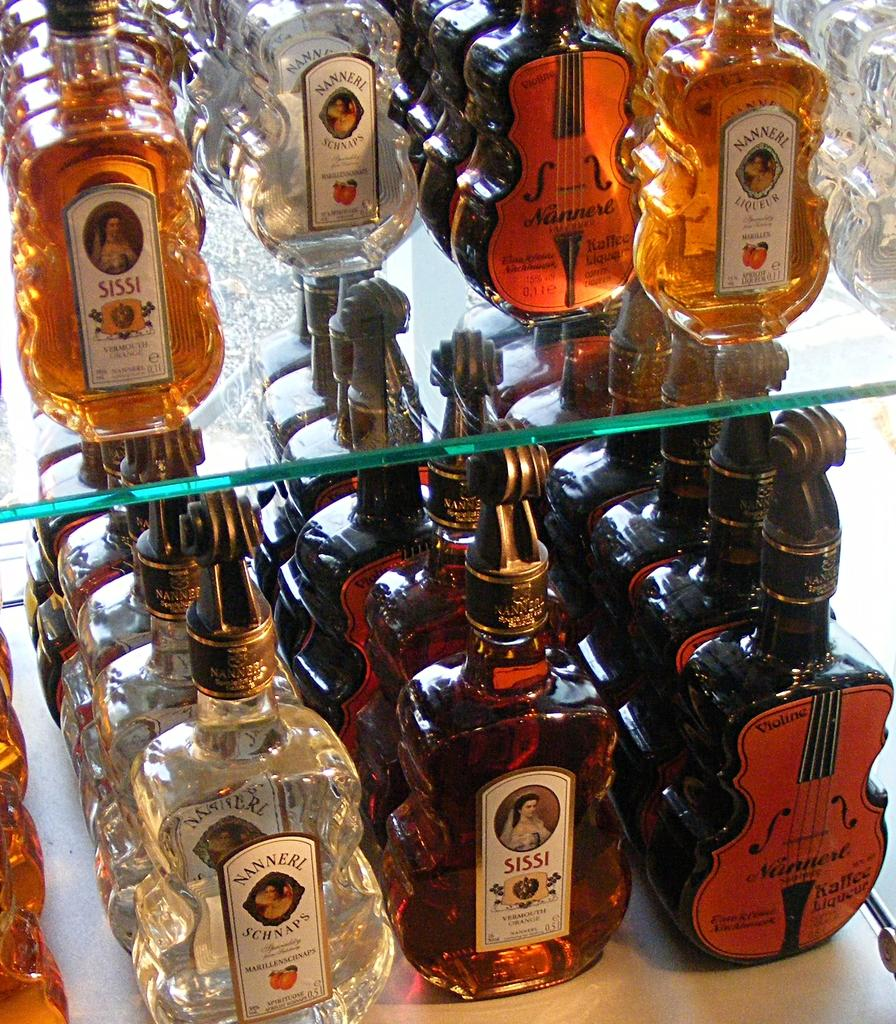<image>
Create a compact narrative representing the image presented. Many bottles of liquor in a display, several of which say Sissi. 